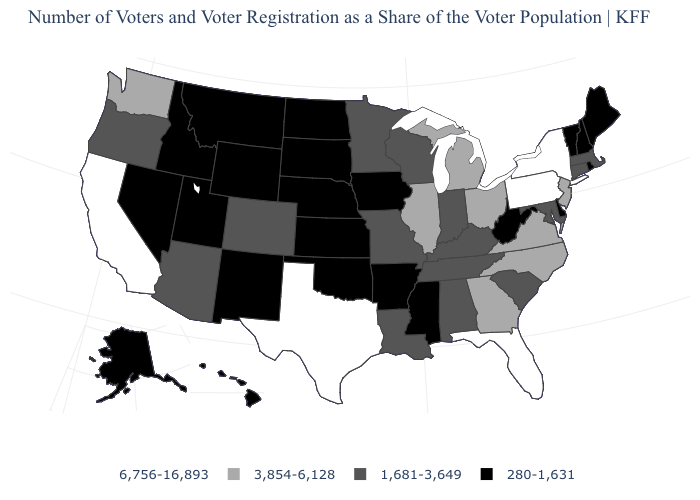Name the states that have a value in the range 1,681-3,649?
Concise answer only. Alabama, Arizona, Colorado, Connecticut, Indiana, Kentucky, Louisiana, Maryland, Massachusetts, Minnesota, Missouri, Oregon, South Carolina, Tennessee, Wisconsin. What is the value of Tennessee?
Answer briefly. 1,681-3,649. How many symbols are there in the legend?
Short answer required. 4. Name the states that have a value in the range 1,681-3,649?
Answer briefly. Alabama, Arizona, Colorado, Connecticut, Indiana, Kentucky, Louisiana, Maryland, Massachusetts, Minnesota, Missouri, Oregon, South Carolina, Tennessee, Wisconsin. What is the highest value in the South ?
Write a very short answer. 6,756-16,893. How many symbols are there in the legend?
Give a very brief answer. 4. What is the highest value in states that border Michigan?
Give a very brief answer. 3,854-6,128. Name the states that have a value in the range 3,854-6,128?
Answer briefly. Georgia, Illinois, Michigan, New Jersey, North Carolina, Ohio, Virginia, Washington. What is the value of Alaska?
Short answer required. 280-1,631. Name the states that have a value in the range 6,756-16,893?
Quick response, please. California, Florida, New York, Pennsylvania, Texas. What is the value of South Carolina?
Write a very short answer. 1,681-3,649. Which states hav the highest value in the South?
Short answer required. Florida, Texas. Name the states that have a value in the range 6,756-16,893?
Be succinct. California, Florida, New York, Pennsylvania, Texas. Does Pennsylvania have the highest value in the Northeast?
Concise answer only. Yes. Name the states that have a value in the range 3,854-6,128?
Answer briefly. Georgia, Illinois, Michigan, New Jersey, North Carolina, Ohio, Virginia, Washington. 